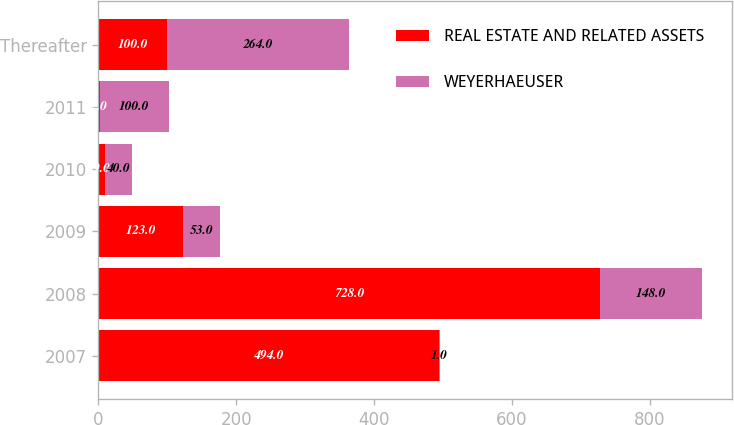Convert chart. <chart><loc_0><loc_0><loc_500><loc_500><stacked_bar_chart><ecel><fcel>2007<fcel>2008<fcel>2009<fcel>2010<fcel>2011<fcel>Thereafter<nl><fcel>REAL ESTATE AND RELATED ASSETS<fcel>494<fcel>728<fcel>123<fcel>9<fcel>2<fcel>100<nl><fcel>WEYERHAEUSER<fcel>1<fcel>148<fcel>53<fcel>40<fcel>100<fcel>264<nl></chart> 